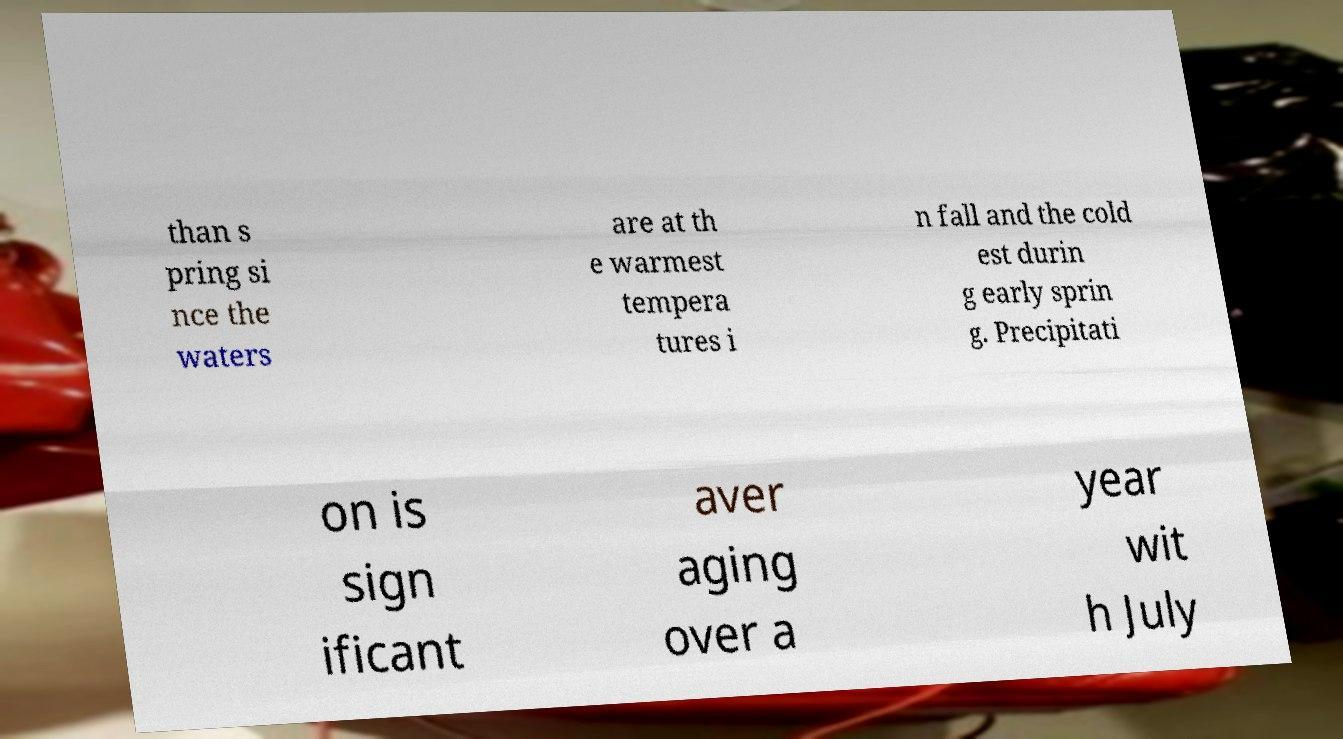What messages or text are displayed in this image? I need them in a readable, typed format. than s pring si nce the waters are at th e warmest tempera tures i n fall and the cold est durin g early sprin g. Precipitati on is sign ificant aver aging over a year wit h July 